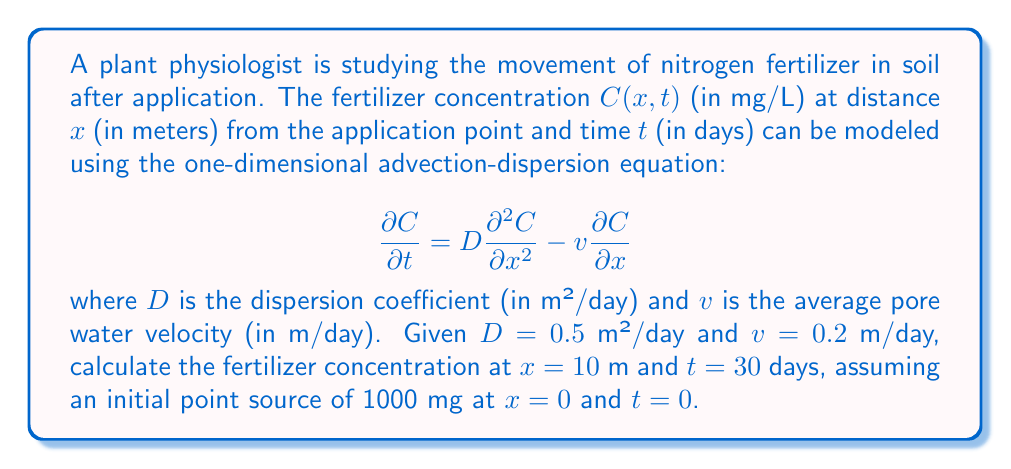Could you help me with this problem? To solve this problem, we need to use the analytical solution of the one-dimensional advection-dispersion equation for a point source initial condition. The solution is given by:

$$C(x,t) = \frac{M}{A\sqrt{4\pi Dt}}\exp\left(-\frac{(x-vt)^2}{4Dt}\right)$$

where:
- $M$ is the initial mass of fertilizer (1000 mg)
- $A$ is the cross-sectional area of flow (assumed to be 1 m² for simplicity)
- $D$ is the dispersion coefficient (0.5 m²/day)
- $v$ is the average pore water velocity (0.2 m/day)
- $x$ is the distance from the source (10 m)
- $t$ is the time since application (30 days)

Let's substitute these values into the equation:

$$C(10,30) = \frac{1000}{1\sqrt{4\pi(0.5)(30)}}\exp\left(-\frac{(10-0.2(30))^2}{4(0.5)(30)}\right)$$

Simplifying:

$$C(10,30) = \frac{1000}{\sqrt{60\pi}}\exp\left(-\frac{(10-6)^2}{60}\right)$$

$$C(10,30) = \frac{1000}{\sqrt{60\pi}}\exp\left(-\frac{16}{60}\right)$$

Now, let's calculate this step by step:
1. $\sqrt{60\pi} \approx 13.7445$
2. $1000 / 13.7445 \approx 72.7563$
3. $16/60 \approx 0.2667$
4. $\exp(-0.2667) \approx 0.7660$

Finally:
$$C(10,30) \approx 72.7563 \times 0.7660 \approx 55.7313 \text{ mg/L}$$
Answer: The fertilizer concentration at $x = 10$ m and $t = 30$ days is approximately 55.73 mg/L. 